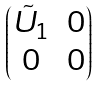Convert formula to latex. <formula><loc_0><loc_0><loc_500><loc_500>\begin{pmatrix} \tilde { U } _ { 1 } & 0 \\ 0 & 0 \end{pmatrix}</formula> 